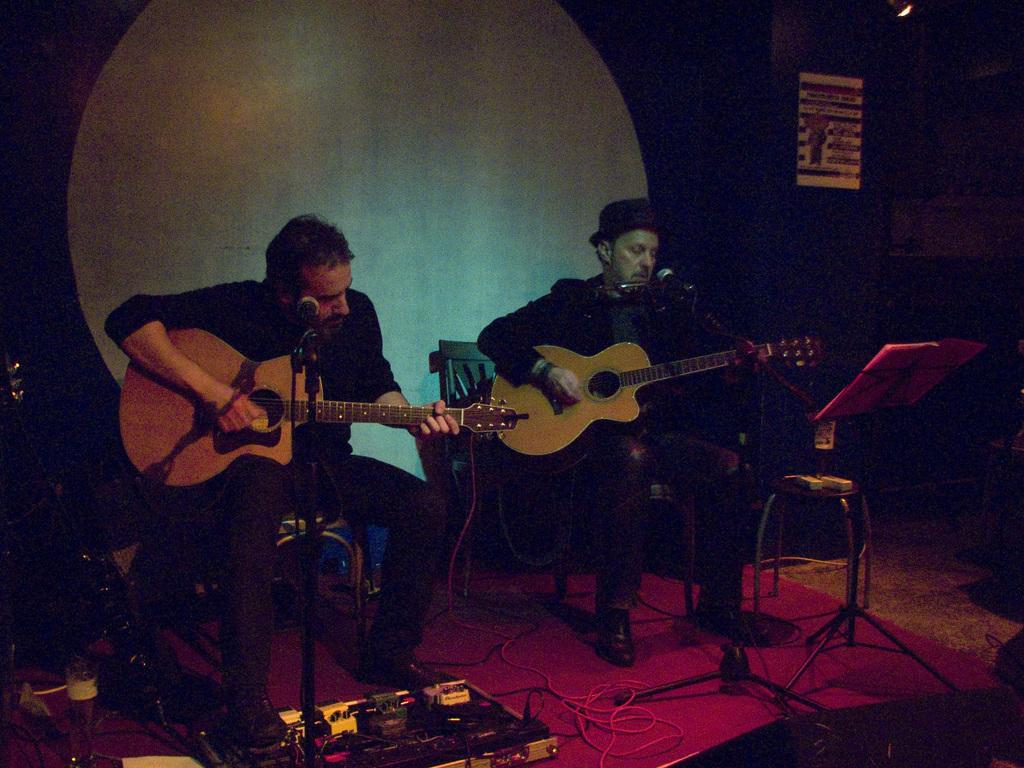How many people are in the image? There are two men in the image. What are the men doing in the image? The men are playing guitars. What are the men sitting on in the image? The men are seated on chairs. What type of cent is being used to measure the length of the guitar strings in the image? There is no cent or measuring device present in the image. 